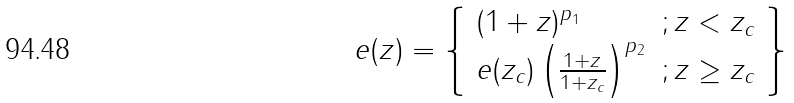<formula> <loc_0><loc_0><loc_500><loc_500>e ( z ) = \left \{ \begin{array} { l c } ( 1 + z ) ^ { p _ { 1 } } & ; z < z _ { c } \\ e ( z _ { c } ) \left ( \frac { 1 + z } { 1 + z _ { c } } \right ) ^ { p _ { 2 } } & ; z \geq z _ { c } \\ \end{array} \right \}</formula> 